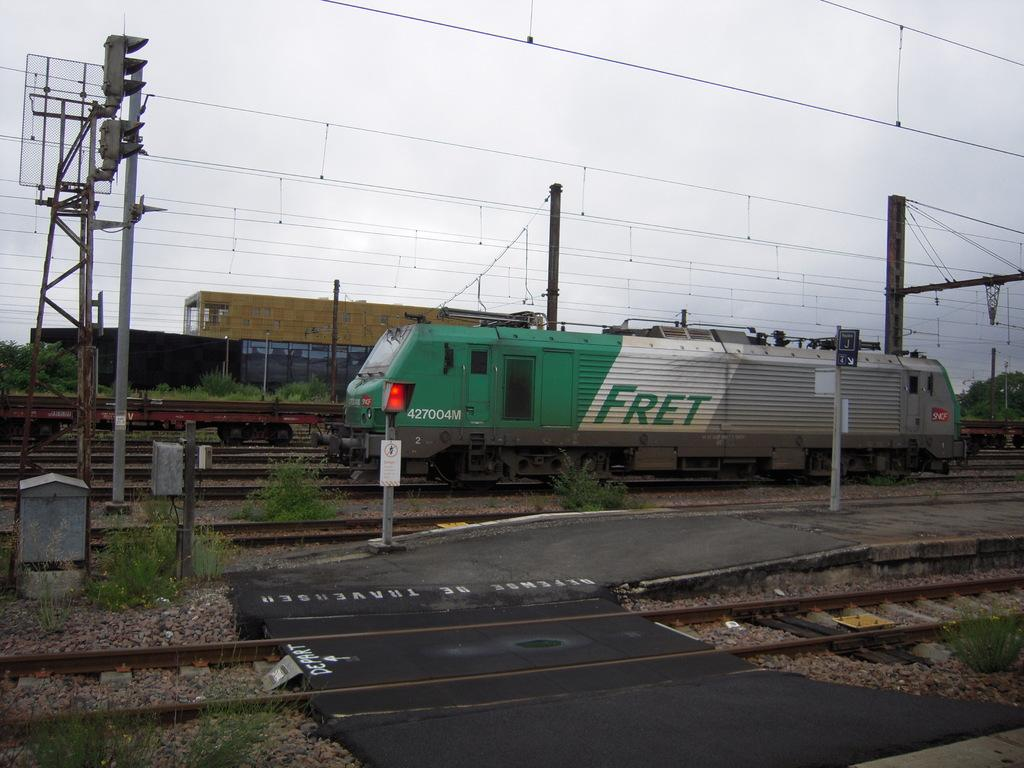Provide a one-sentence caption for the provided image. A green, white and gray train with the text fret on the middle white section. 